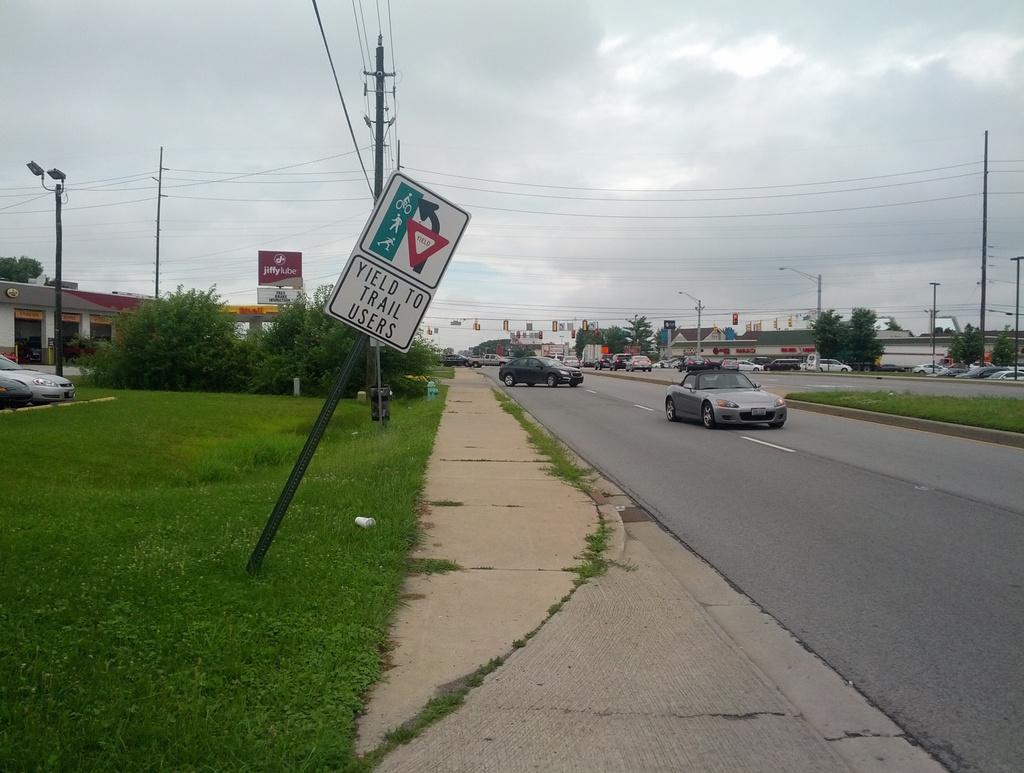What should you do for train users?
Offer a very short reply. Yield. Which users should you yield to?
Your response must be concise. Trail users. 